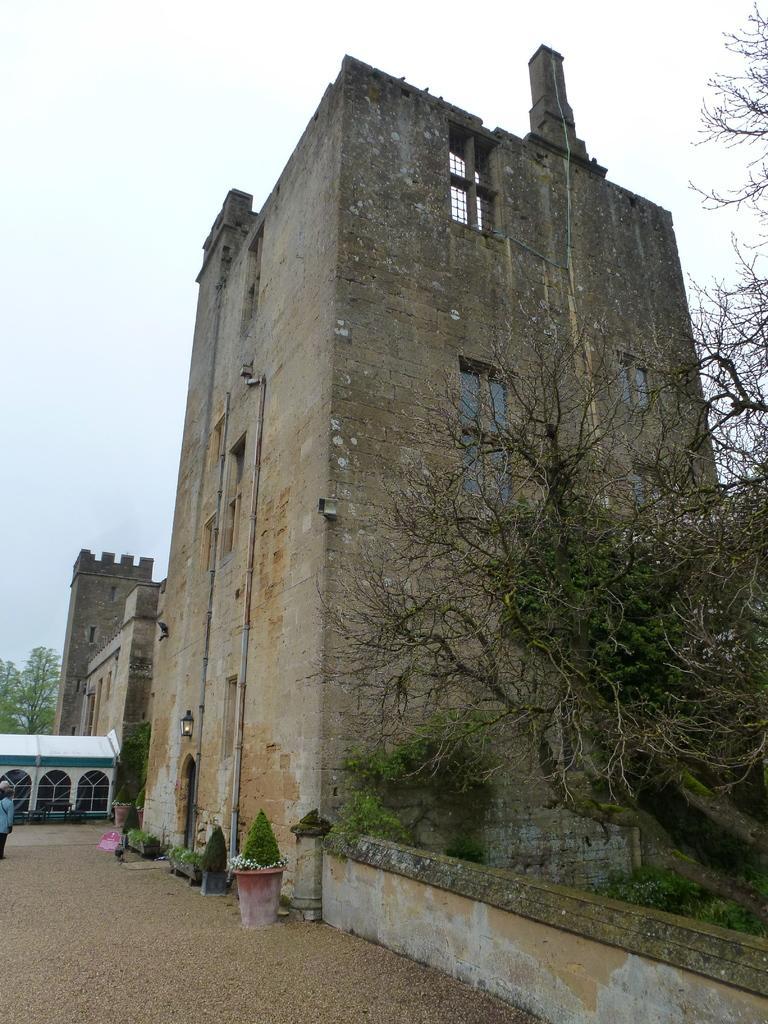Can you describe this image briefly? This picture is clicked outside. In the center we can see the houseplants and there is a person. On the right we can see a plant and a tree and we can see the buildings. In the background there is a sky and the trees. 